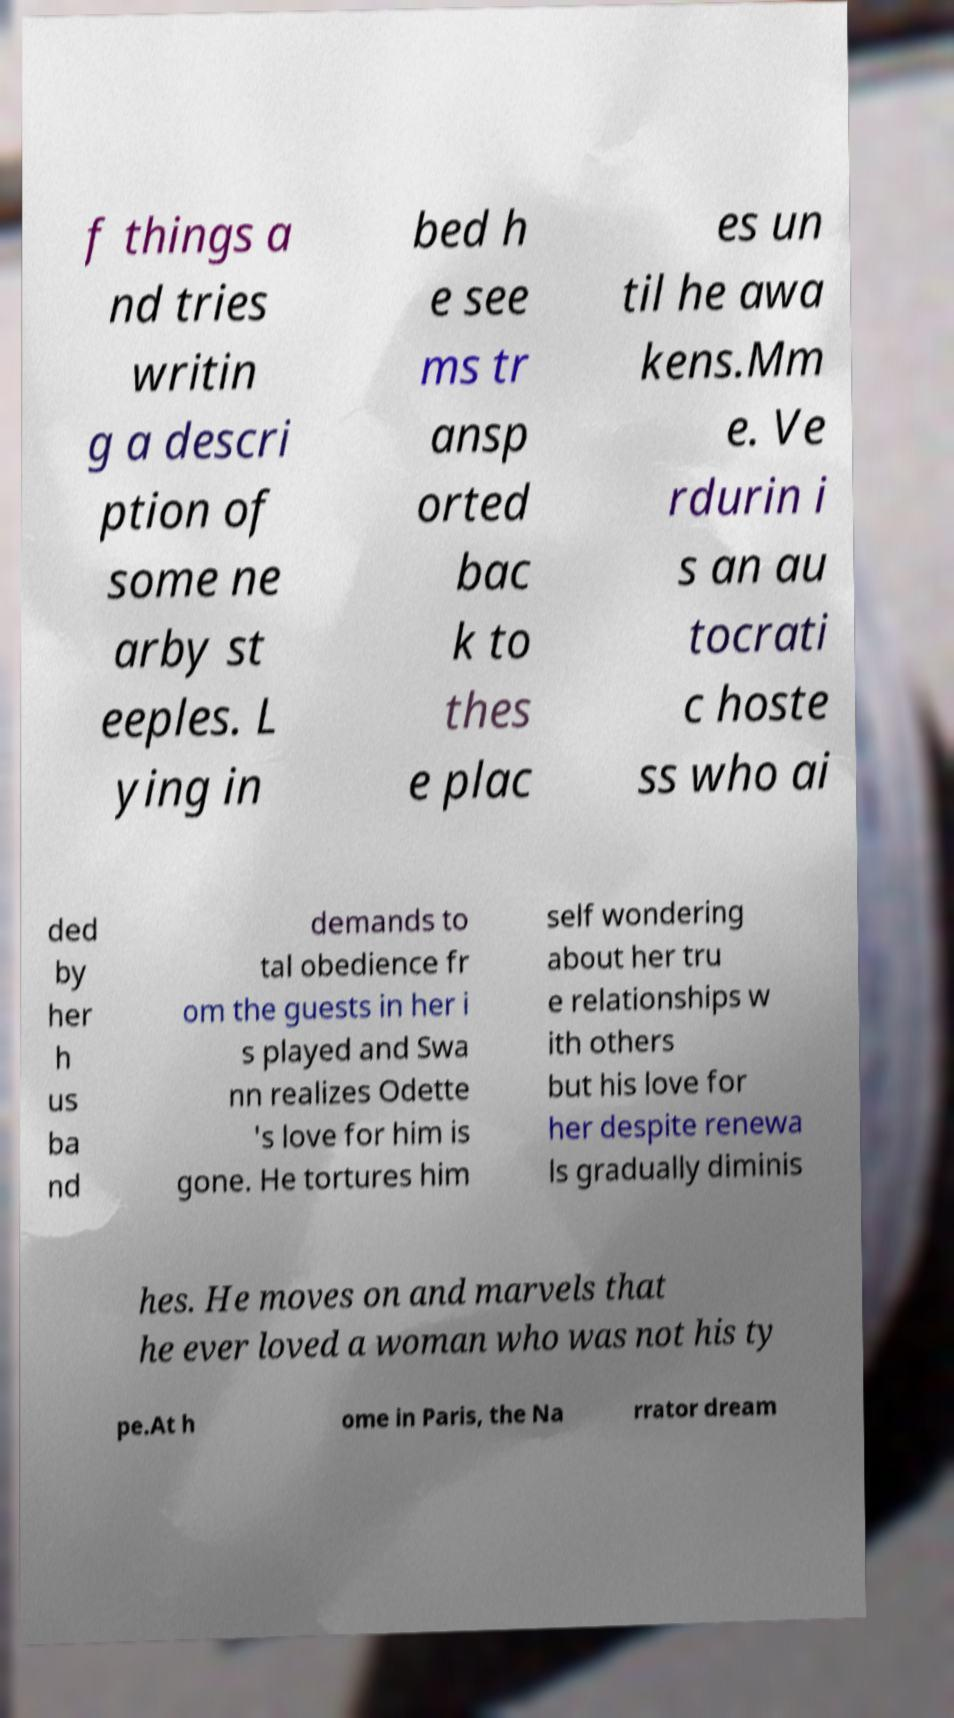What messages or text are displayed in this image? I need them in a readable, typed format. f things a nd tries writin g a descri ption of some ne arby st eeples. L ying in bed h e see ms tr ansp orted bac k to thes e plac es un til he awa kens.Mm e. Ve rdurin i s an au tocrati c hoste ss who ai ded by her h us ba nd demands to tal obedience fr om the guests in her i s played and Swa nn realizes Odette 's love for him is gone. He tortures him self wondering about her tru e relationships w ith others but his love for her despite renewa ls gradually diminis hes. He moves on and marvels that he ever loved a woman who was not his ty pe.At h ome in Paris, the Na rrator dream 